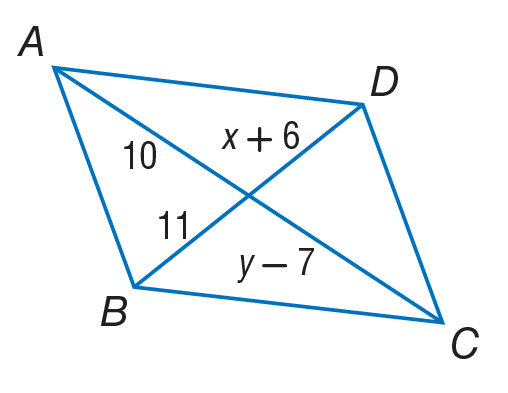Answer the mathemtical geometry problem and directly provide the correct option letter.
Question: Use parallelogram to, find y.
Choices: A: 5 B: 10 C: 11 D: 17 D 